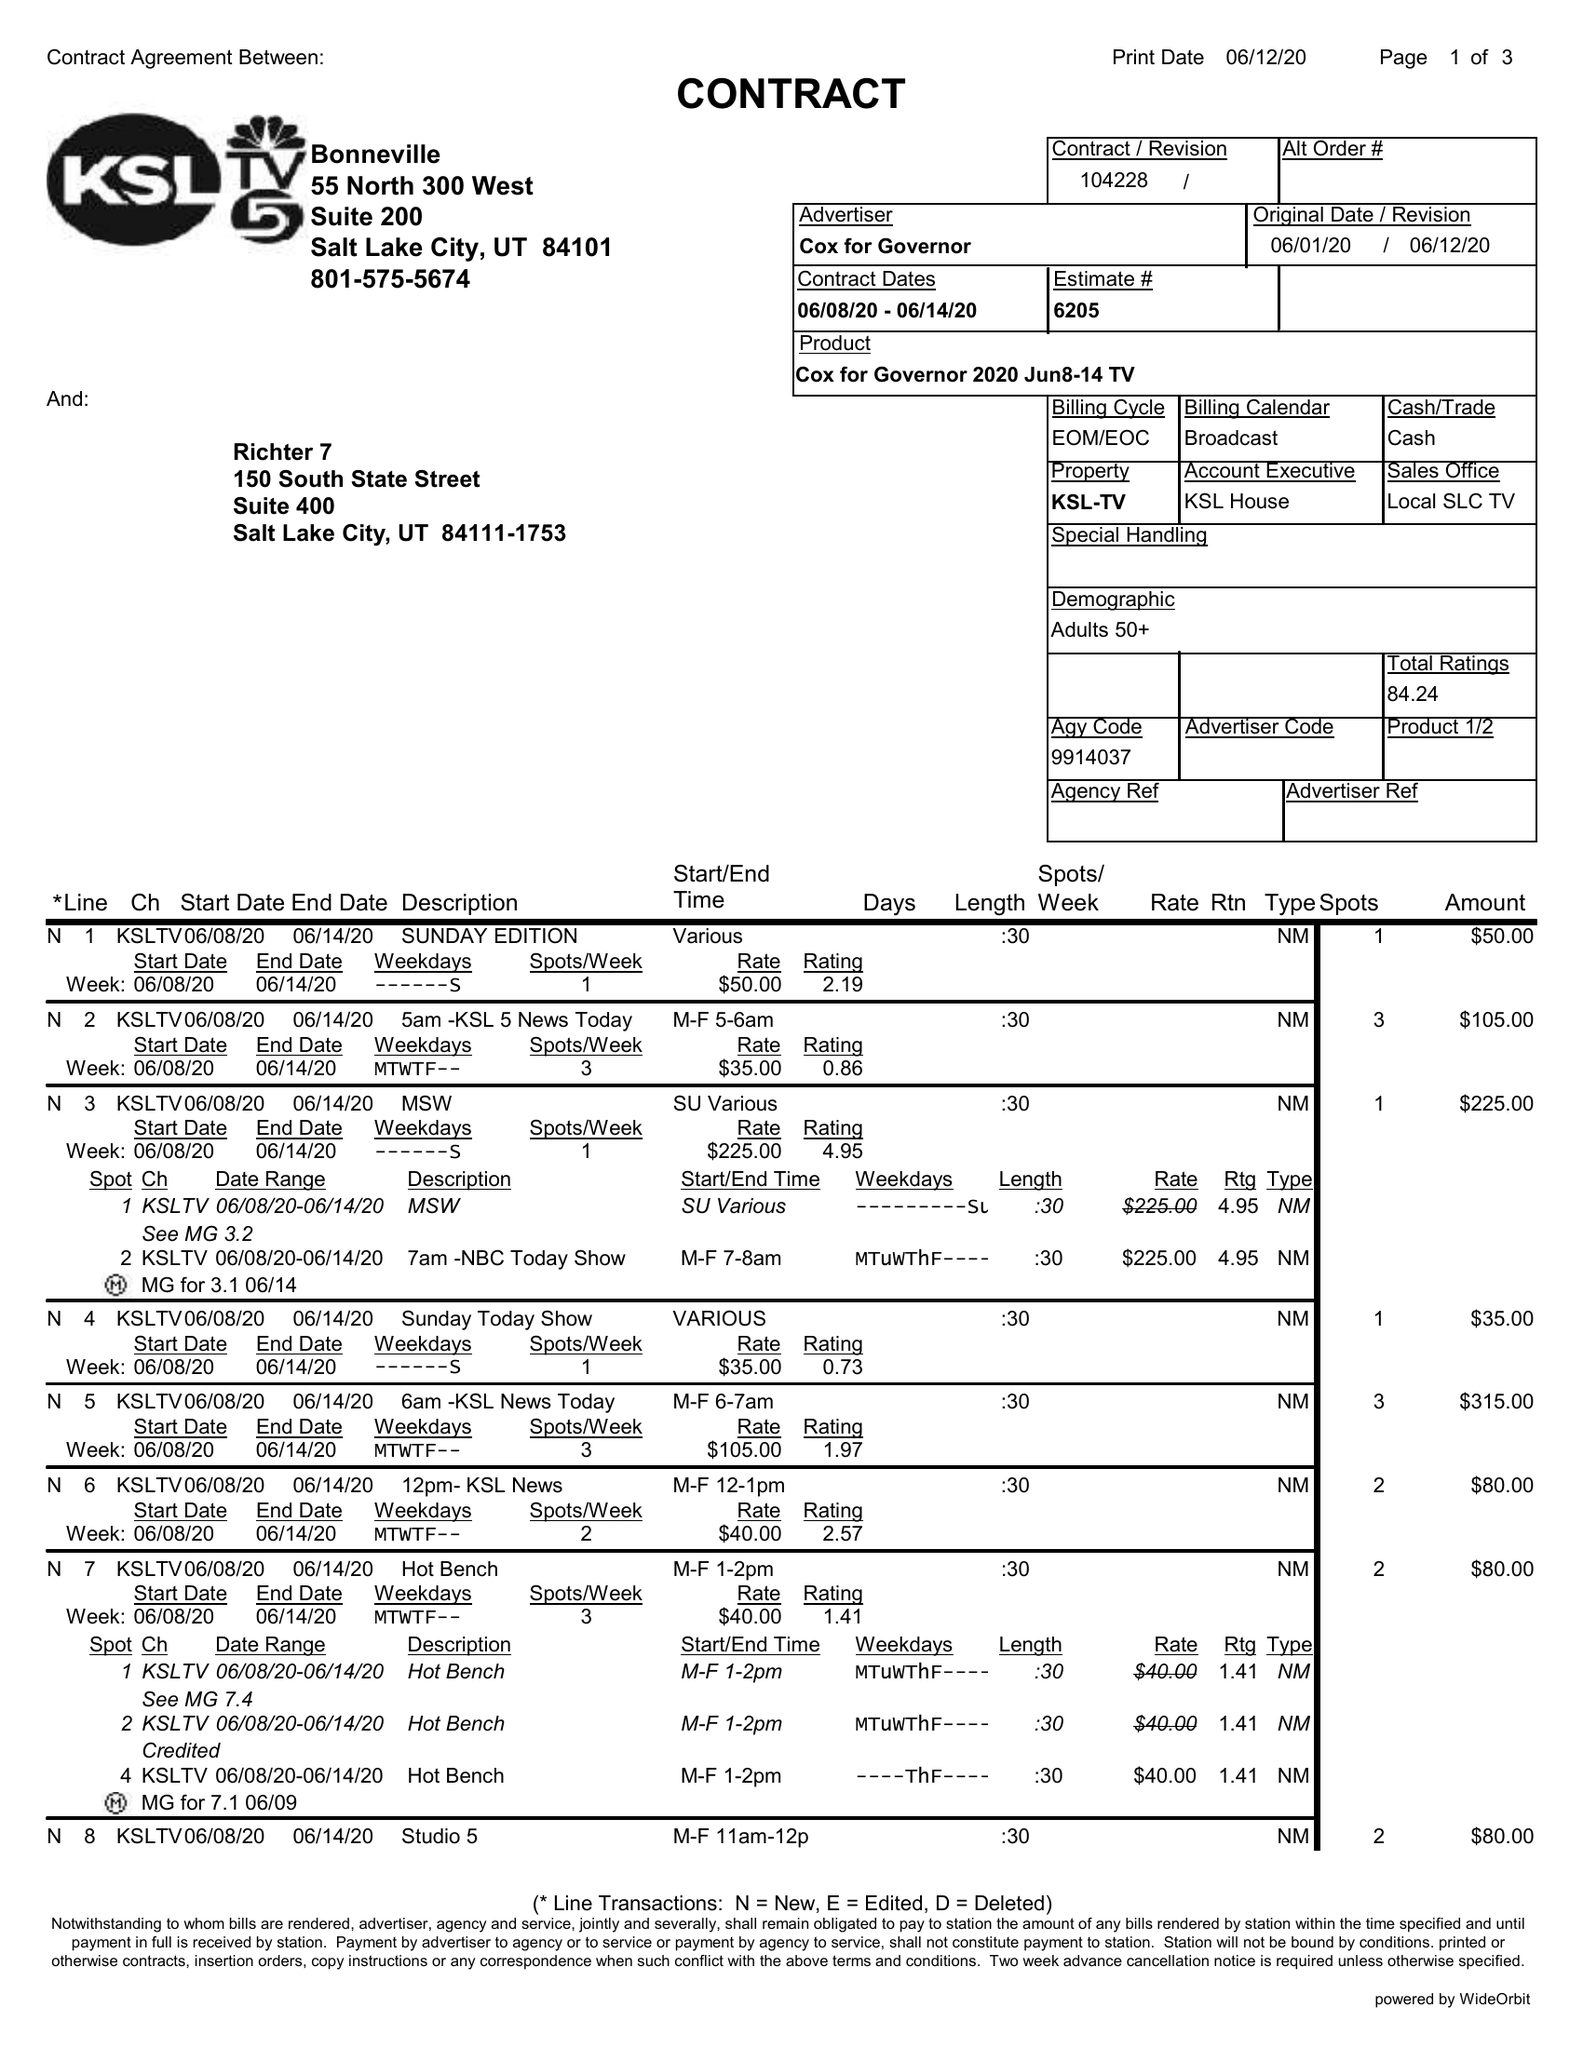What is the value for the gross_amount?
Answer the question using a single word or phrase. 4575.00 